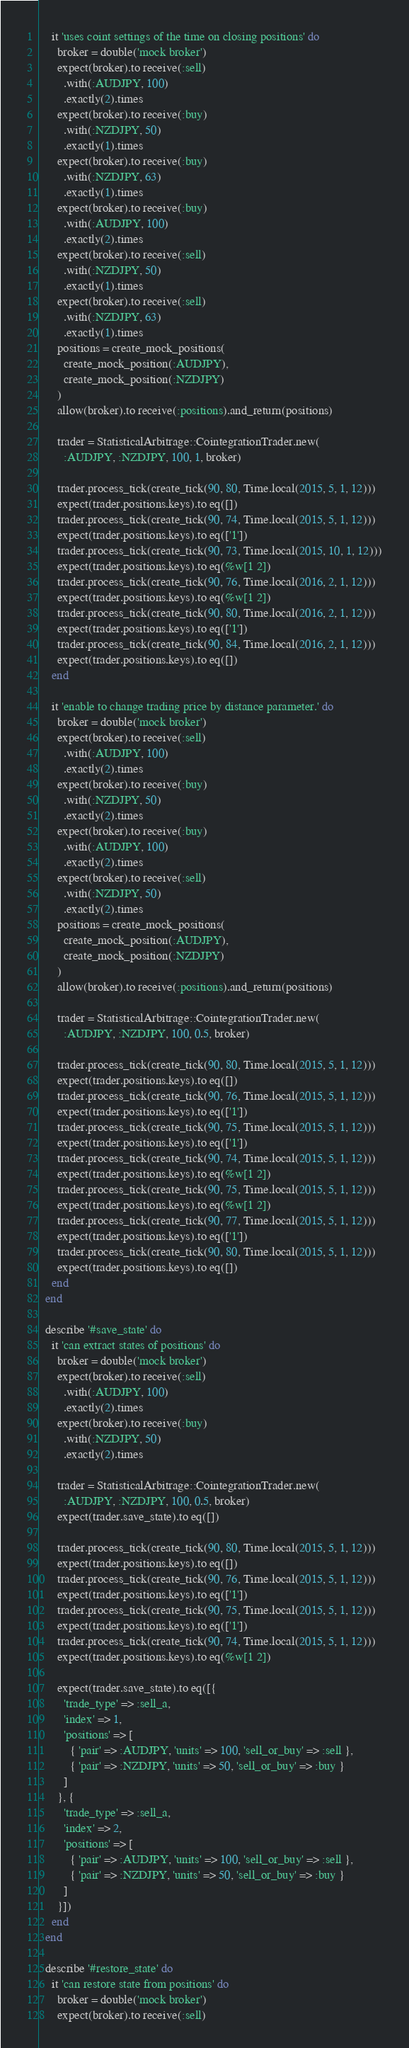Convert code to text. <code><loc_0><loc_0><loc_500><loc_500><_Ruby_>
    it 'uses coint settings of the time on closing positions' do
      broker = double('mock broker')
      expect(broker).to receive(:sell)
        .with(:AUDJPY, 100)
        .exactly(2).times
      expect(broker).to receive(:buy)
        .with(:NZDJPY, 50)
        .exactly(1).times
      expect(broker).to receive(:buy)
        .with(:NZDJPY, 63)
        .exactly(1).times
      expect(broker).to receive(:buy)
        .with(:AUDJPY, 100)
        .exactly(2).times
      expect(broker).to receive(:sell)
        .with(:NZDJPY, 50)
        .exactly(1).times
      expect(broker).to receive(:sell)
        .with(:NZDJPY, 63)
        .exactly(1).times
      positions = create_mock_positions(
        create_mock_position(:AUDJPY),
        create_mock_position(:NZDJPY)
      )
      allow(broker).to receive(:positions).and_return(positions)

      trader = StatisticalArbitrage::CointegrationTrader.new(
        :AUDJPY, :NZDJPY, 100, 1, broker)

      trader.process_tick(create_tick(90, 80, Time.local(2015, 5, 1, 12)))
      expect(trader.positions.keys).to eq([])
      trader.process_tick(create_tick(90, 74, Time.local(2015, 5, 1, 12)))
      expect(trader.positions.keys).to eq(['1'])
      trader.process_tick(create_tick(90, 73, Time.local(2015, 10, 1, 12)))
      expect(trader.positions.keys).to eq(%w[1 2])
      trader.process_tick(create_tick(90, 76, Time.local(2016, 2, 1, 12)))
      expect(trader.positions.keys).to eq(%w[1 2])
      trader.process_tick(create_tick(90, 80, Time.local(2016, 2, 1, 12)))
      expect(trader.positions.keys).to eq(['1'])
      trader.process_tick(create_tick(90, 84, Time.local(2016, 2, 1, 12)))
      expect(trader.positions.keys).to eq([])
    end

    it 'enable to change trading price by distance parameter.' do
      broker = double('mock broker')
      expect(broker).to receive(:sell)
        .with(:AUDJPY, 100)
        .exactly(2).times
      expect(broker).to receive(:buy)
        .with(:NZDJPY, 50)
        .exactly(2).times
      expect(broker).to receive(:buy)
        .with(:AUDJPY, 100)
        .exactly(2).times
      expect(broker).to receive(:sell)
        .with(:NZDJPY, 50)
        .exactly(2).times
      positions = create_mock_positions(
        create_mock_position(:AUDJPY),
        create_mock_position(:NZDJPY)
      )
      allow(broker).to receive(:positions).and_return(positions)

      trader = StatisticalArbitrage::CointegrationTrader.new(
        :AUDJPY, :NZDJPY, 100, 0.5, broker)

      trader.process_tick(create_tick(90, 80, Time.local(2015, 5, 1, 12)))
      expect(trader.positions.keys).to eq([])
      trader.process_tick(create_tick(90, 76, Time.local(2015, 5, 1, 12)))
      expect(trader.positions.keys).to eq(['1'])
      trader.process_tick(create_tick(90, 75, Time.local(2015, 5, 1, 12)))
      expect(trader.positions.keys).to eq(['1'])
      trader.process_tick(create_tick(90, 74, Time.local(2015, 5, 1, 12)))
      expect(trader.positions.keys).to eq(%w[1 2])
      trader.process_tick(create_tick(90, 75, Time.local(2015, 5, 1, 12)))
      expect(trader.positions.keys).to eq(%w[1 2])
      trader.process_tick(create_tick(90, 77, Time.local(2015, 5, 1, 12)))
      expect(trader.positions.keys).to eq(['1'])
      trader.process_tick(create_tick(90, 80, Time.local(2015, 5, 1, 12)))
      expect(trader.positions.keys).to eq([])
    end
  end

  describe '#save_state' do
    it 'can extract states of positions' do
      broker = double('mock broker')
      expect(broker).to receive(:sell)
        .with(:AUDJPY, 100)
        .exactly(2).times
      expect(broker).to receive(:buy)
        .with(:NZDJPY, 50)
        .exactly(2).times

      trader = StatisticalArbitrage::CointegrationTrader.new(
        :AUDJPY, :NZDJPY, 100, 0.5, broker)
      expect(trader.save_state).to eq([])

      trader.process_tick(create_tick(90, 80, Time.local(2015, 5, 1, 12)))
      expect(trader.positions.keys).to eq([])
      trader.process_tick(create_tick(90, 76, Time.local(2015, 5, 1, 12)))
      expect(trader.positions.keys).to eq(['1'])
      trader.process_tick(create_tick(90, 75, Time.local(2015, 5, 1, 12)))
      expect(trader.positions.keys).to eq(['1'])
      trader.process_tick(create_tick(90, 74, Time.local(2015, 5, 1, 12)))
      expect(trader.positions.keys).to eq(%w[1 2])

      expect(trader.save_state).to eq([{
        'trade_type' => :sell_a,
        'index' => 1,
        'positions' => [
          { 'pair' => :AUDJPY, 'units' => 100, 'sell_or_buy' => :sell },
          { 'pair' => :NZDJPY, 'units' => 50, 'sell_or_buy' => :buy }
        ]
      }, {
        'trade_type' => :sell_a,
        'index' => 2,
        'positions' => [
          { 'pair' => :AUDJPY, 'units' => 100, 'sell_or_buy' => :sell },
          { 'pair' => :NZDJPY, 'units' => 50, 'sell_or_buy' => :buy }
        ]
      }])
    end
  end

  describe '#restore_state' do
    it 'can restore state from positions' do
      broker = double('mock broker')
      expect(broker).to receive(:sell)</code> 